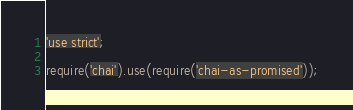<code> <loc_0><loc_0><loc_500><loc_500><_JavaScript_>'use strict';

require('chai').use(require('chai-as-promised'));
</code> 